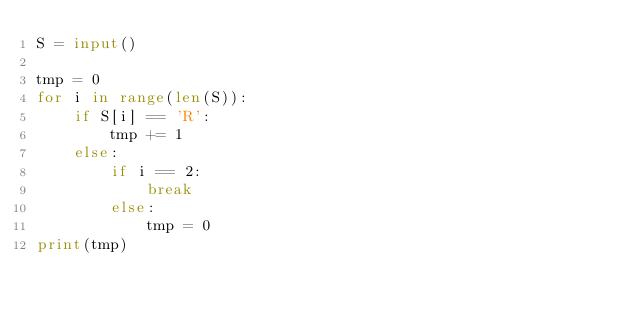<code> <loc_0><loc_0><loc_500><loc_500><_Python_>S = input()

tmp = 0
for i in range(len(S)):
    if S[i] == 'R':
        tmp += 1
    else:
        if i == 2:
            break
        else:
            tmp = 0
print(tmp)            
</code> 